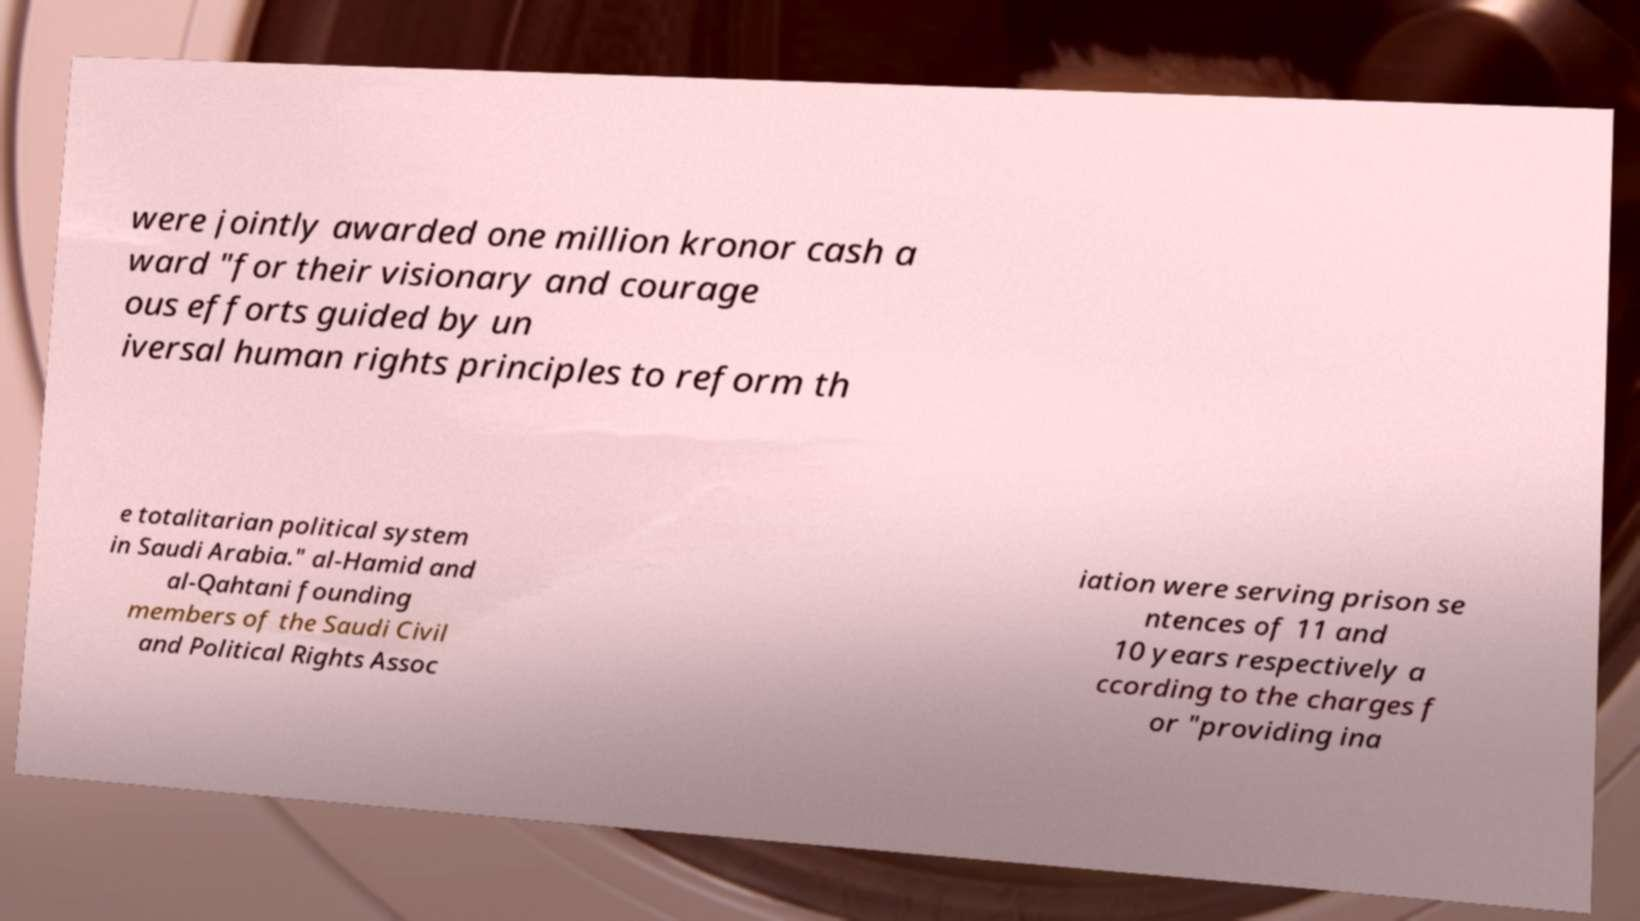I need the written content from this picture converted into text. Can you do that? were jointly awarded one million kronor cash a ward "for their visionary and courage ous efforts guided by un iversal human rights principles to reform th e totalitarian political system in Saudi Arabia." al-Hamid and al-Qahtani founding members of the Saudi Civil and Political Rights Assoc iation were serving prison se ntences of 11 and 10 years respectively a ccording to the charges f or "providing ina 